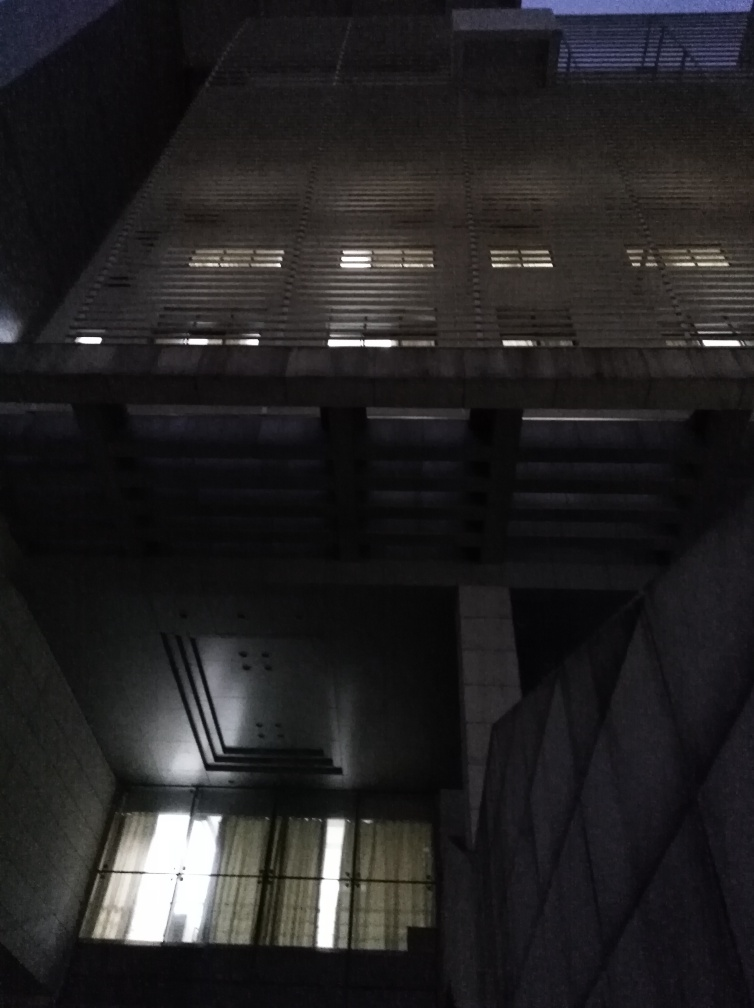What architectural style might this building represent? Based on the limited visible details, the building could be categorized as modern or post-modern architecture, characterized by its functional form, repetitive patterns, and seemingly utilitarian materials. Can anything be said about the function or use of this building? The building's repetitive structure and the uniformity of windows suggest it could be a commercial or residential building. The fortified nature of its construction implies it may have been designed with a specific purpose in mind, such as privacy or security. 